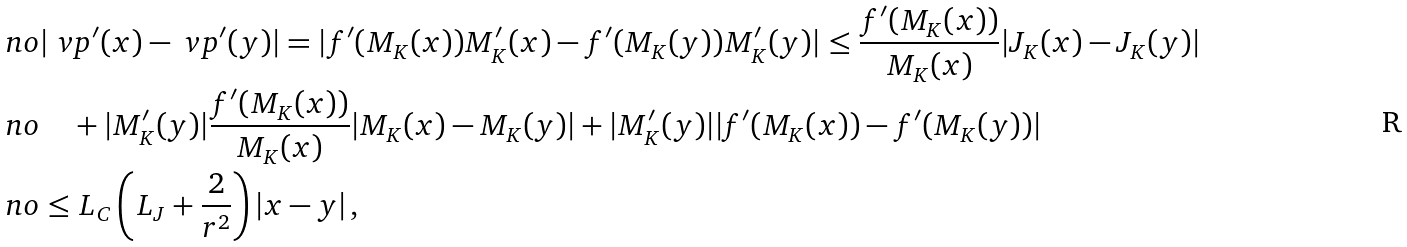Convert formula to latex. <formula><loc_0><loc_0><loc_500><loc_500>\ n o & | \ v p ^ { \prime } ( x ) - \ v p ^ { \prime } ( y ) | = | f ^ { \prime } ( M _ { K } ( x ) ) M _ { K } ^ { \prime } ( x ) - f ^ { \prime } ( M _ { K } ( y ) ) M _ { K } ^ { \prime } ( y ) | \leq \frac { f ^ { \prime } ( M _ { K } ( x ) ) } { M _ { K } ( x ) } | J _ { K } ( x ) - J _ { K } ( y ) | \\ \ n o & \quad + | M _ { K } ^ { \prime } ( y ) | \frac { f ^ { \prime } ( M _ { K } ( x ) ) } { M _ { K } ( x ) } | M _ { K } ( x ) - M _ { K } ( y ) | + | M _ { K } ^ { \prime } ( y ) | | f ^ { \prime } ( M _ { K } ( x ) ) - f ^ { \prime } ( M _ { K } ( y ) ) | \\ \ n o & \leq L _ { C } \left ( L _ { J } + \frac { 2 } { r ^ { 2 } } \right ) | x - y | \, ,</formula> 